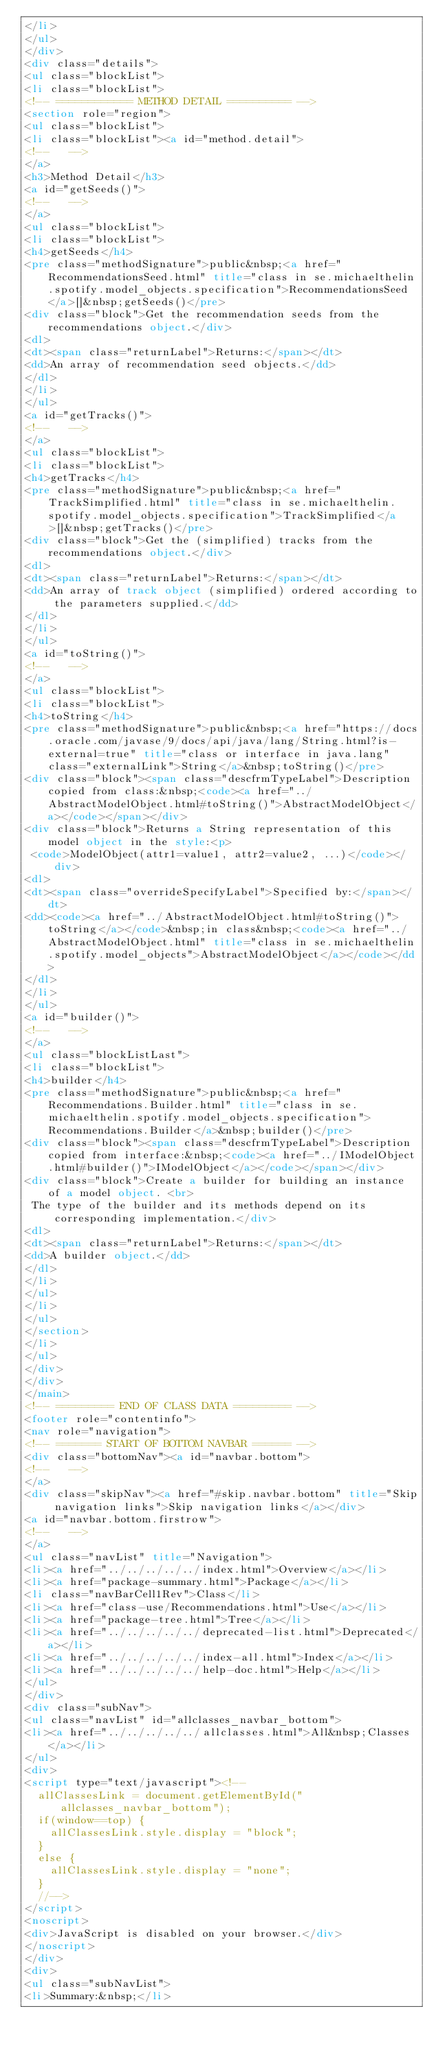<code> <loc_0><loc_0><loc_500><loc_500><_HTML_></li>
</ul>
</div>
<div class="details">
<ul class="blockList">
<li class="blockList">
<!-- ============ METHOD DETAIL ========== -->
<section role="region">
<ul class="blockList">
<li class="blockList"><a id="method.detail">
<!--   -->
</a>
<h3>Method Detail</h3>
<a id="getSeeds()">
<!--   -->
</a>
<ul class="blockList">
<li class="blockList">
<h4>getSeeds</h4>
<pre class="methodSignature">public&nbsp;<a href="RecommendationsSeed.html" title="class in se.michaelthelin.spotify.model_objects.specification">RecommendationsSeed</a>[]&nbsp;getSeeds()</pre>
<div class="block">Get the recommendation seeds from the recommendations object.</div>
<dl>
<dt><span class="returnLabel">Returns:</span></dt>
<dd>An array of recommendation seed objects.</dd>
</dl>
</li>
</ul>
<a id="getTracks()">
<!--   -->
</a>
<ul class="blockList">
<li class="blockList">
<h4>getTracks</h4>
<pre class="methodSignature">public&nbsp;<a href="TrackSimplified.html" title="class in se.michaelthelin.spotify.model_objects.specification">TrackSimplified</a>[]&nbsp;getTracks()</pre>
<div class="block">Get the (simplified) tracks from the recommendations object.</div>
<dl>
<dt><span class="returnLabel">Returns:</span></dt>
<dd>An array of track object (simplified) ordered according to the parameters supplied.</dd>
</dl>
</li>
</ul>
<a id="toString()">
<!--   -->
</a>
<ul class="blockList">
<li class="blockList">
<h4>toString</h4>
<pre class="methodSignature">public&nbsp;<a href="https://docs.oracle.com/javase/9/docs/api/java/lang/String.html?is-external=true" title="class or interface in java.lang" class="externalLink">String</a>&nbsp;toString()</pre>
<div class="block"><span class="descfrmTypeLabel">Description copied from class:&nbsp;<code><a href="../AbstractModelObject.html#toString()">AbstractModelObject</a></code></span></div>
<div class="block">Returns a String representation of this model object in the style:<p>
 <code>ModelObject(attr1=value1, attr2=value2, ...)</code></div>
<dl>
<dt><span class="overrideSpecifyLabel">Specified by:</span></dt>
<dd><code><a href="../AbstractModelObject.html#toString()">toString</a></code>&nbsp;in class&nbsp;<code><a href="../AbstractModelObject.html" title="class in se.michaelthelin.spotify.model_objects">AbstractModelObject</a></code></dd>
</dl>
</li>
</ul>
<a id="builder()">
<!--   -->
</a>
<ul class="blockListLast">
<li class="blockList">
<h4>builder</h4>
<pre class="methodSignature">public&nbsp;<a href="Recommendations.Builder.html" title="class in se.michaelthelin.spotify.model_objects.specification">Recommendations.Builder</a>&nbsp;builder()</pre>
<div class="block"><span class="descfrmTypeLabel">Description copied from interface:&nbsp;<code><a href="../IModelObject.html#builder()">IModelObject</a></code></span></div>
<div class="block">Create a builder for building an instance of a model object. <br>
 The type of the builder and its methods depend on its corresponding implementation.</div>
<dl>
<dt><span class="returnLabel">Returns:</span></dt>
<dd>A builder object.</dd>
</dl>
</li>
</ul>
</li>
</ul>
</section>
</li>
</ul>
</div>
</div>
</main>
<!-- ========= END OF CLASS DATA ========= -->
<footer role="contentinfo">
<nav role="navigation">
<!-- ======= START OF BOTTOM NAVBAR ====== -->
<div class="bottomNav"><a id="navbar.bottom">
<!--   -->
</a>
<div class="skipNav"><a href="#skip.navbar.bottom" title="Skip navigation links">Skip navigation links</a></div>
<a id="navbar.bottom.firstrow">
<!--   -->
</a>
<ul class="navList" title="Navigation">
<li><a href="../../../../../index.html">Overview</a></li>
<li><a href="package-summary.html">Package</a></li>
<li class="navBarCell1Rev">Class</li>
<li><a href="class-use/Recommendations.html">Use</a></li>
<li><a href="package-tree.html">Tree</a></li>
<li><a href="../../../../../deprecated-list.html">Deprecated</a></li>
<li><a href="../../../../../index-all.html">Index</a></li>
<li><a href="../../../../../help-doc.html">Help</a></li>
</ul>
</div>
<div class="subNav">
<ul class="navList" id="allclasses_navbar_bottom">
<li><a href="../../../../../allclasses.html">All&nbsp;Classes</a></li>
</ul>
<div>
<script type="text/javascript"><!--
  allClassesLink = document.getElementById("allclasses_navbar_bottom");
  if(window==top) {
    allClassesLink.style.display = "block";
  }
  else {
    allClassesLink.style.display = "none";
  }
  //-->
</script>
<noscript>
<div>JavaScript is disabled on your browser.</div>
</noscript>
</div>
<div>
<ul class="subNavList">
<li>Summary:&nbsp;</li></code> 